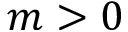Convert formula to latex. <formula><loc_0><loc_0><loc_500><loc_500>m > 0</formula> 